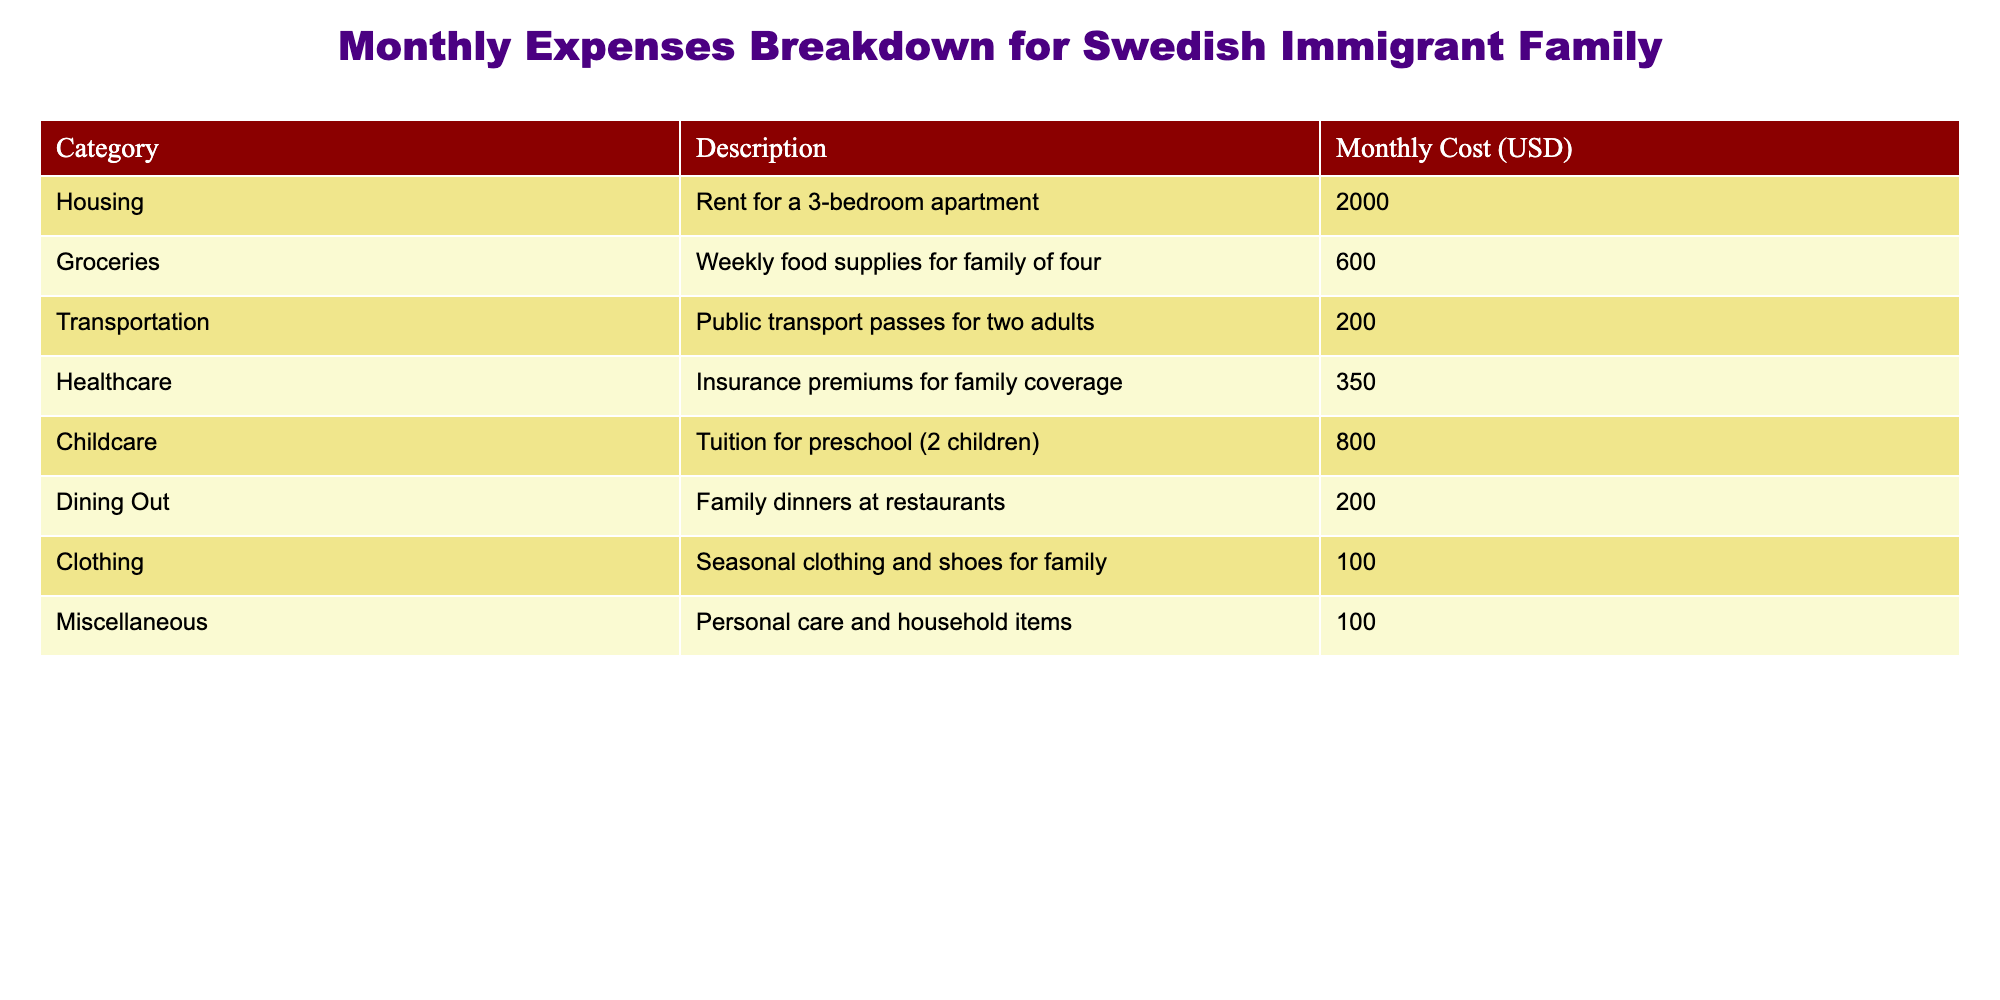What is the total monthly cost for housing and healthcare combined? To find the total monthly cost for housing and healthcare, we will first identify the individual costs from the table: Housing is 2000 USD, and Healthcare is 350 USD. We then add these two amounts together: 2000 + 350 = 2350.
Answer: 2350 How much is spent on groceries compared to dining out? From the table, the monthly cost for groceries is 600 USD, while dining out costs 200 USD. To compare these, we can see that groceries are 600 - 200 = 400 USD more than dining out.
Answer: 400 Is the monthly expense for childcare higher than the combined expense for transportation and clothing? The expense for childcare is 800 USD. The transportation cost is 200 USD, and clothing is 100 USD. To find the combined expense for transportation and clothing, we add those two costs: 200 + 100 = 300. Since 800 is greater than 300, the answer is true.
Answer: Yes What is the average monthly spending on miscellaneous items and clothing? The monthly expenses for miscellaneous items and clothing are both 100 USD, so we can find the average by adding both amounts together: 100 + 100 = 200, and then dividing that by the number of categories, which is 2. Thus, the average is 200 / 2 = 100.
Answer: 100 What percentage of the total monthly expense is spent on housing? First, we need to find the total monthly expenses. We sum all the costs: 2000 + 600 + 200 + 350 + 800 + 200 + 100 + 100 = 4350 USD. Now, we calculate the percentage for housing, which is 2000 USD. The percentage is calculated as (2000 / 4350) * 100, which equals approximately 45.98%.
Answer: 45.98% What is the total cost for all categories except for dining out? We will sum all the expenses listed, except dining out, which is 200 USD. The costs we sum are: 2000 + 600 + 200 + 350 + 800 + 100 + 100 = 4150.
Answer: 4150 Is the combined cost of groceries and childcare equal to the total of healthcare and transportation? From the table, groceries are 600 USD and childcare is 800 USD, which combine to 600 + 800 = 1400. Healthcare is 350 USD and transportation is 200 USD, combining to 350 + 200 = 550. Since 1400 is not equal to 550, the answer is false.
Answer: No 